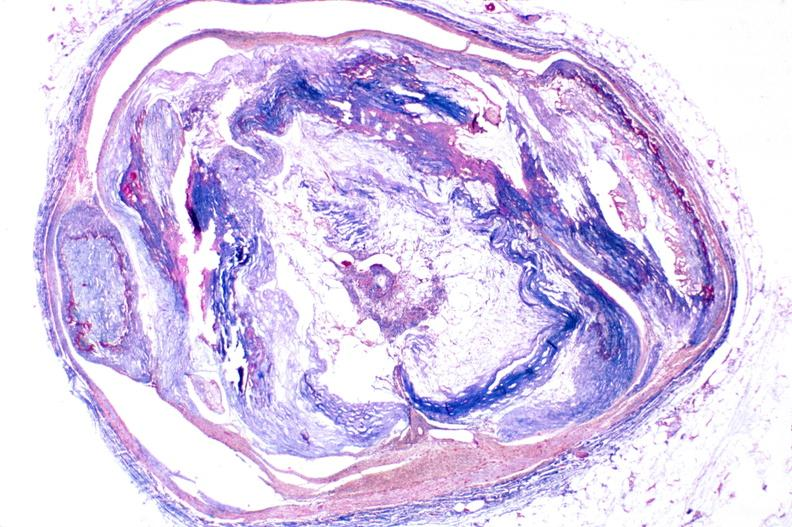does this image show atherosclerosis, right coronary artery?
Answer the question using a single word or phrase. Yes 